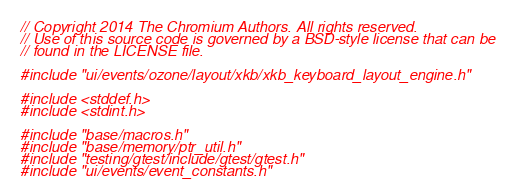<code> <loc_0><loc_0><loc_500><loc_500><_C++_>// Copyright 2014 The Chromium Authors. All rights reserved.
// Use of this source code is governed by a BSD-style license that can be
// found in the LICENSE file.

#include "ui/events/ozone/layout/xkb/xkb_keyboard_layout_engine.h"

#include <stddef.h>
#include <stdint.h>

#include "base/macros.h"
#include "base/memory/ptr_util.h"
#include "testing/gtest/include/gtest/gtest.h"
#include "ui/events/event_constants.h"</code> 